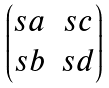<formula> <loc_0><loc_0><loc_500><loc_500>\begin{pmatrix} s a & s c \\ s b & s d \end{pmatrix}</formula> 